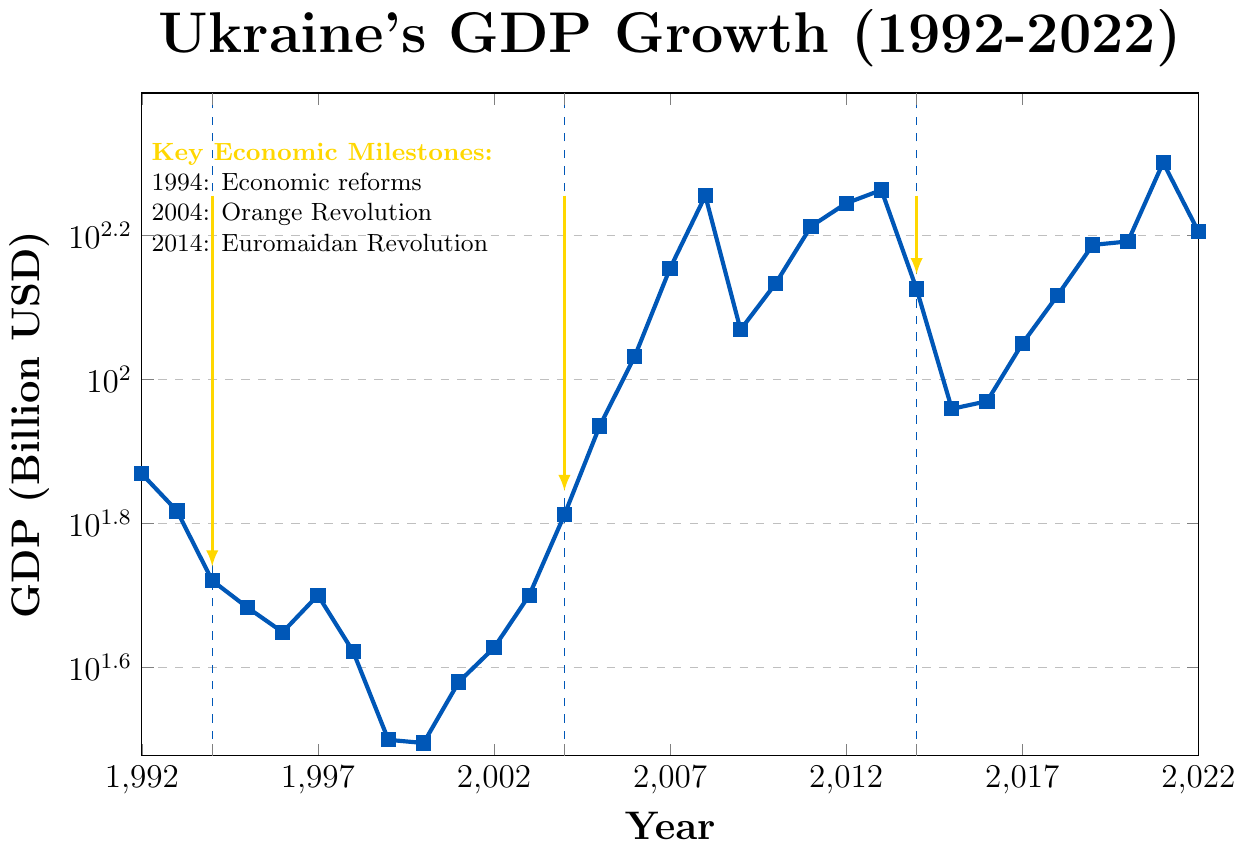What is the GDP of Ukraine in 2008? The chart shows the GDP value for each year as a blue square. Look for the value marked in 2008.
Answer: 179.99 billion USD What was the trend in Ukraine's GDP between 1992 and 1999? Observe the values from 1992 to 1999 and note whether the values generally increase, decrease, or remain constant. From 73.94 billion USD in 1992, Ukraine's GDP generally decreases to 31.26 billion USD in 1999.
Answer: Decreasing During which years did Ukraine's GDP exceed 100 billion USD? Identify the points where the GDP exceeds 100 billion USD on the y-axis, and note the corresponding years from the x-axis. These years are 2006, 2007, 2008, 2010, 2011, 2012, 2013, 2017, 2018, 2019, 2020, 2021, and 2022.
Answer: 2006-2008, 2010-2013, 2017-2022 How did the GDP in 2014 compare to 2013? Find the GDP values for both years and compare them. In 2013, it was 183.31 billion USD, and in 2014, it dropped to 133.50 billion USD.
Answer: Decreased What economic milestone is marked in the chart around 2014 and how does it relate to GDP? See the annotations for economic milestones. The Euromaidan Revolution is marked in 2014. Correspondingly, the GDP dropped from 183.31 billion USD in 2013 to 133.50 billion USD in 2014.
Answer: Euromaidan Revolution; GDP decreased Which year saw the highest GDP within the period covered? Check the highest data point on the chart. The highest GDP of 200.09 billion USD occurs in 2021.
Answer: 2021 How does the GDP in 2000 compare with GDP in 1999? Provide the percentage change. Compare the GDP values: 31.26 billion USD in 2000 and 31.58 billion USD in 1999. Calculate the percentage change: ((31.26 - 31.58) / 31.58) * 100 = -1.01%.
Answer: -1.01% Between which years did the GDP of Ukraine more than double? Look at the years where the GDP value more than doubled compared to a previous year. From 1999 (31.58 billion USD) to 2004 (64.88 billion USD), the GDP more than doubled.
Answer: 1999 to 2004 What were the general trends in Ukraine's GDP before and after the Orange Revolution in 2004? Identify the GDP trend before 2004 and after. Before 2004, the GDP increases from 42.39 billion USD in 2002 to 64.88 billion USD in 2004. After 2004, the GDP continues to increase up to 179.99 billion USD in 2008.
Answer: Increasing before and after 